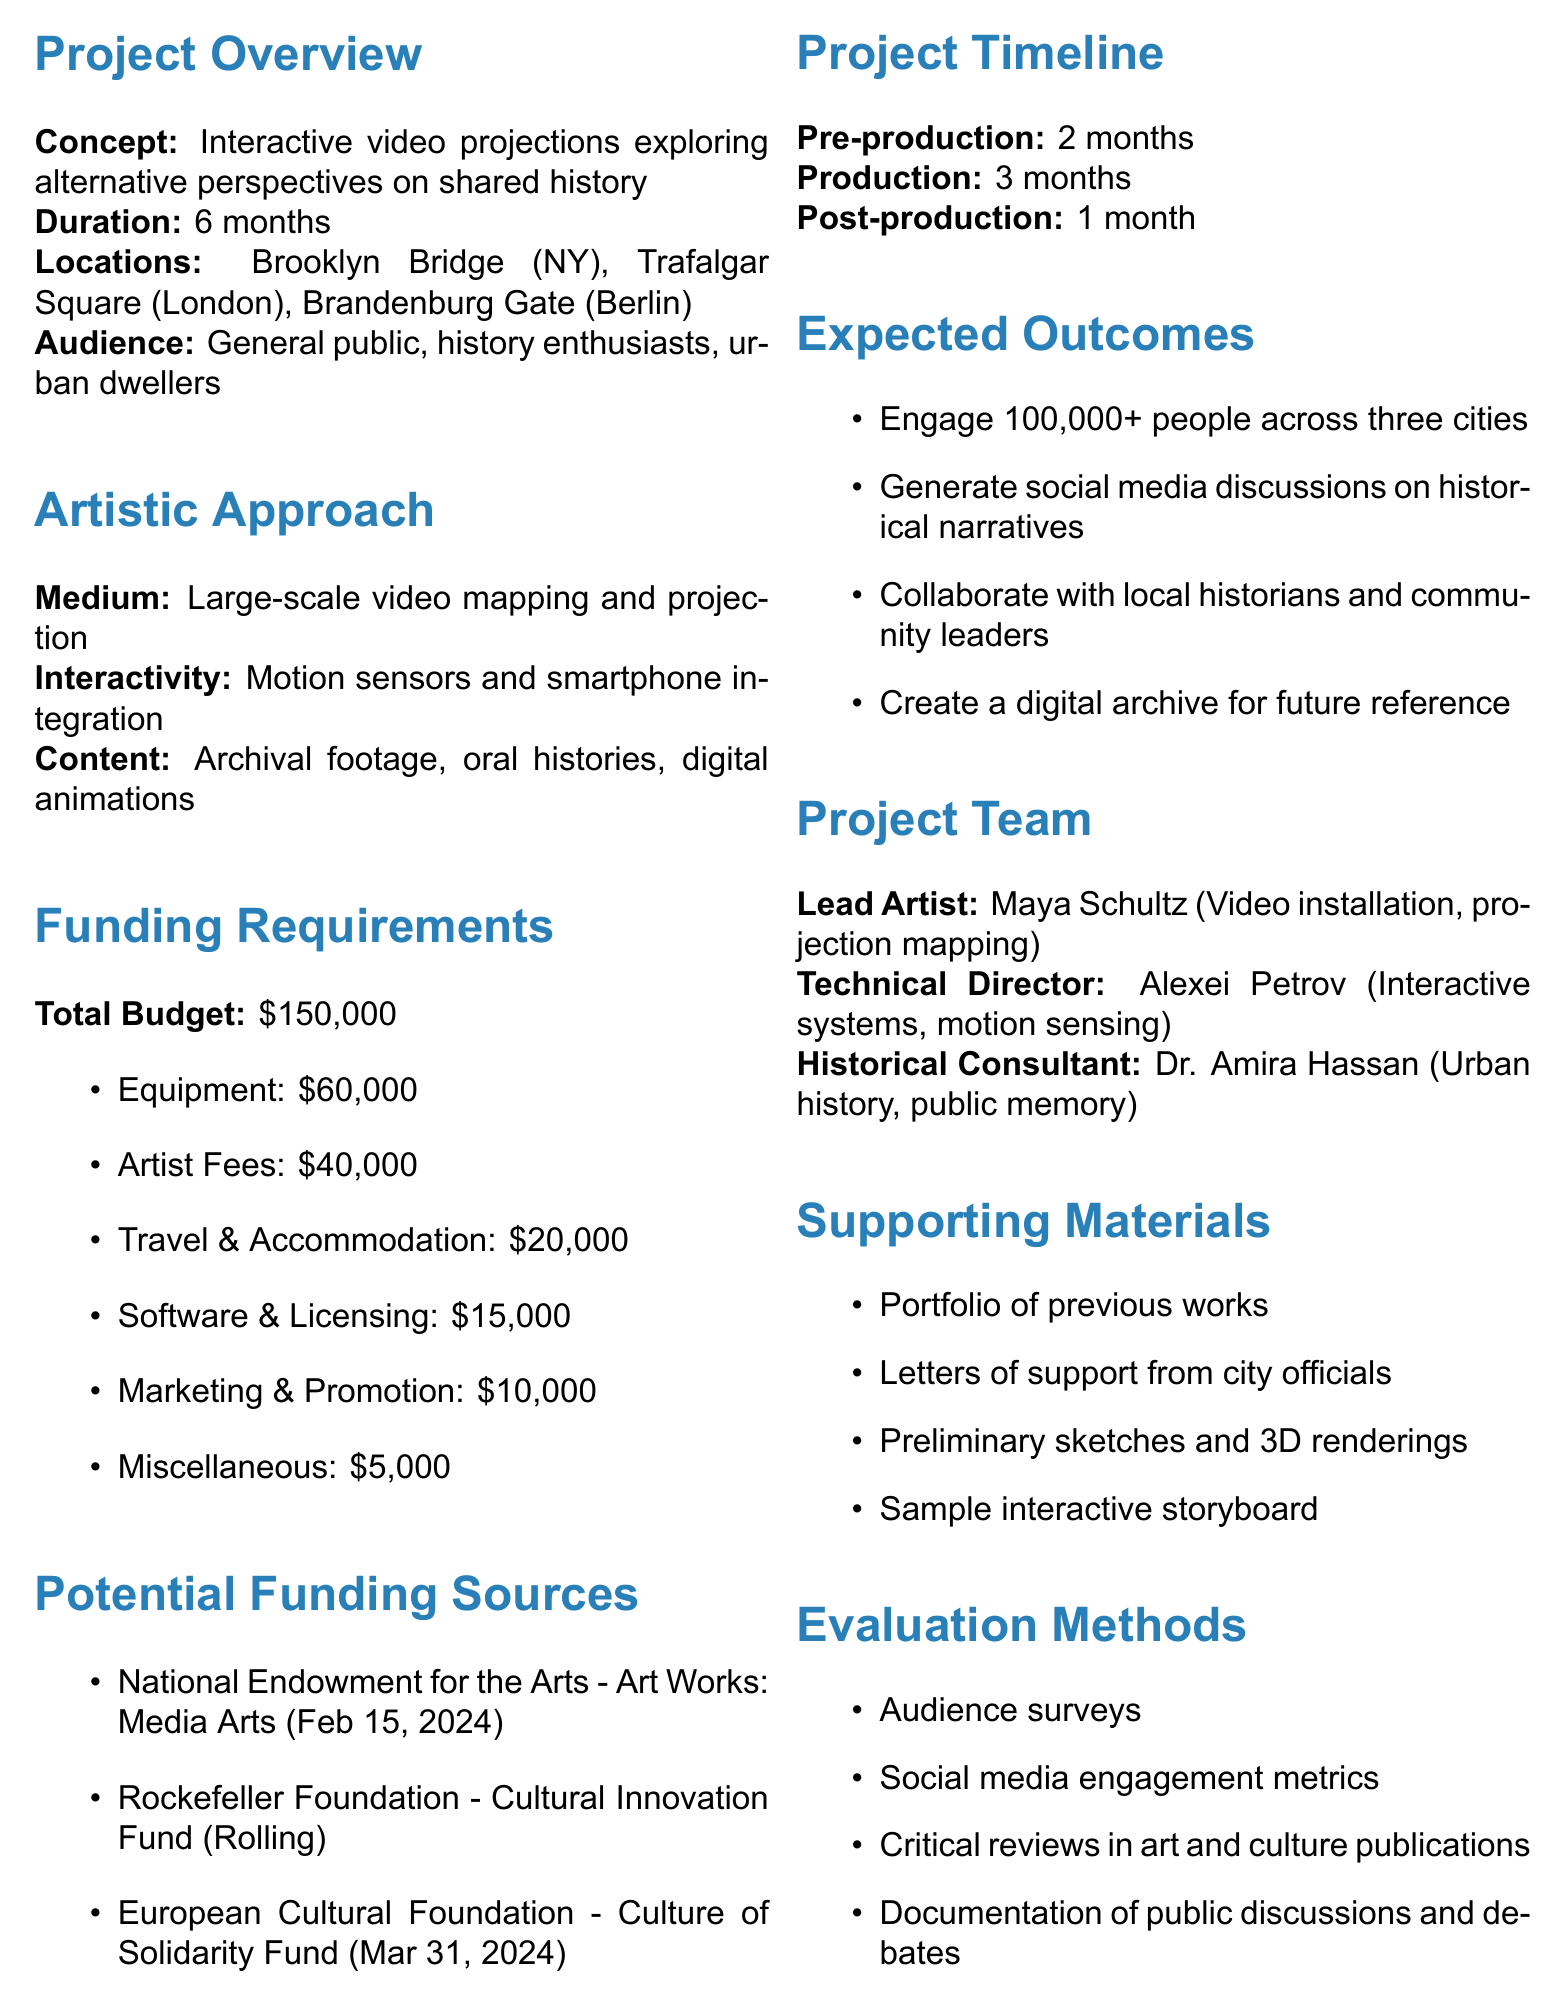What is the project title? The project title can be found in the document's heading, which specifies the name of the project.
Answer: Urban Palimpsest: Reframing History Through Interactive Video Projections How long is the project duration? The duration of the project is explicitly mentioned in the project overview section.
Answer: 6 months What is the total budget required for the project? The total budget is listed in the funding requirements section, indicating the overall financial needs for the project.
Answer: $150,000 Which city is not one of the project locations? The locations are listed in the project overview; identifying which city is missing requires knowledge of the provided cities.
Answer: New York Who is the Historical Consultant for the project? The document specifies the roles and names of team members, providing insight into each person's expertise.
Answer: Dr. Amira Hassan What type of artistic approach is being used? The artistic approach section details the medium and methods involved in the project, allowing for understanding of the project's execution.
Answer: Large-scale video mapping and projection What is one expected outcome of the project? Expected outcomes are listed in the document, summarizing the project's goals and its intended impact.
Answer: Engage over 100,000 people across three cities What evaluation method is mentioned for assessing the project's success? The evaluation methods are outlined and include various ways to gauge the project's effectiveness.
Answer: Audience surveys 